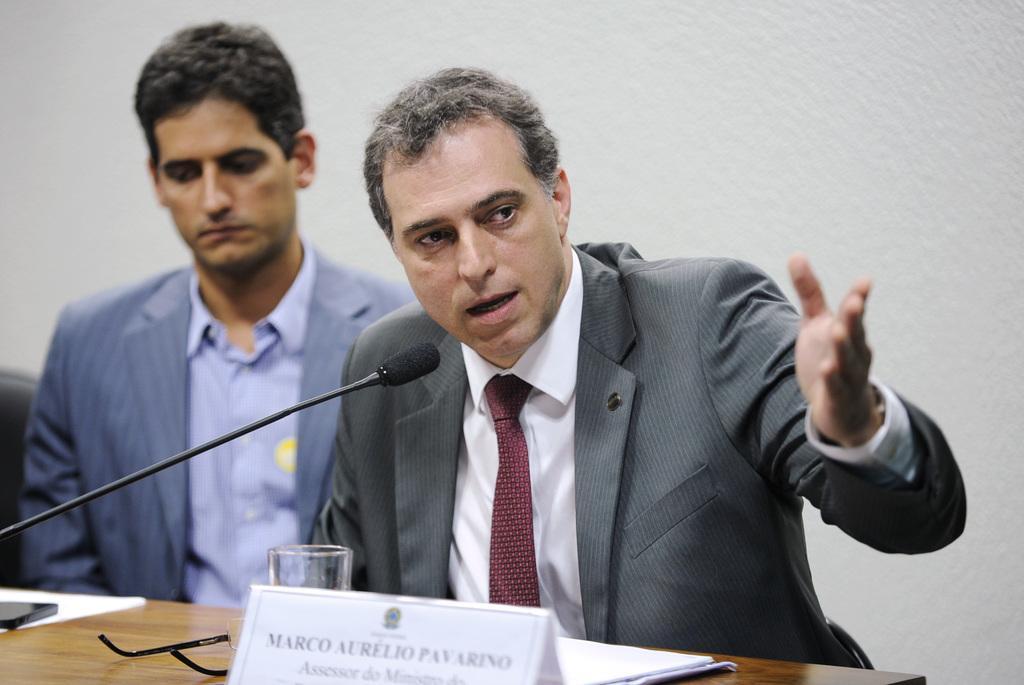Could you give a brief overview of what you see in this image? Here in this picture we can see two men sitting on chairs with table in front of them having papers, mobile phone, spectacles and glass and a name board present on it over there and we can also see a microphone present on the table over there and the person in the front is speaking something in the microphone present in front of him over there. 